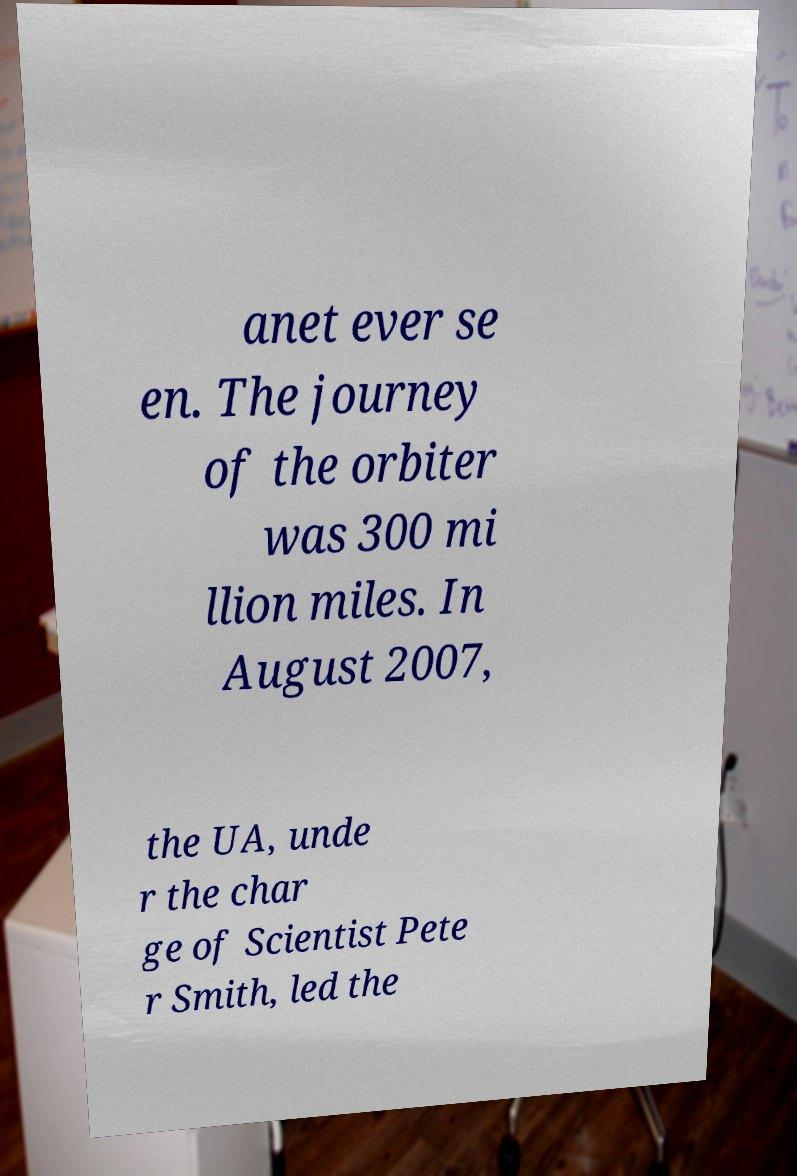There's text embedded in this image that I need extracted. Can you transcribe it verbatim? anet ever se en. The journey of the orbiter was 300 mi llion miles. In August 2007, the UA, unde r the char ge of Scientist Pete r Smith, led the 